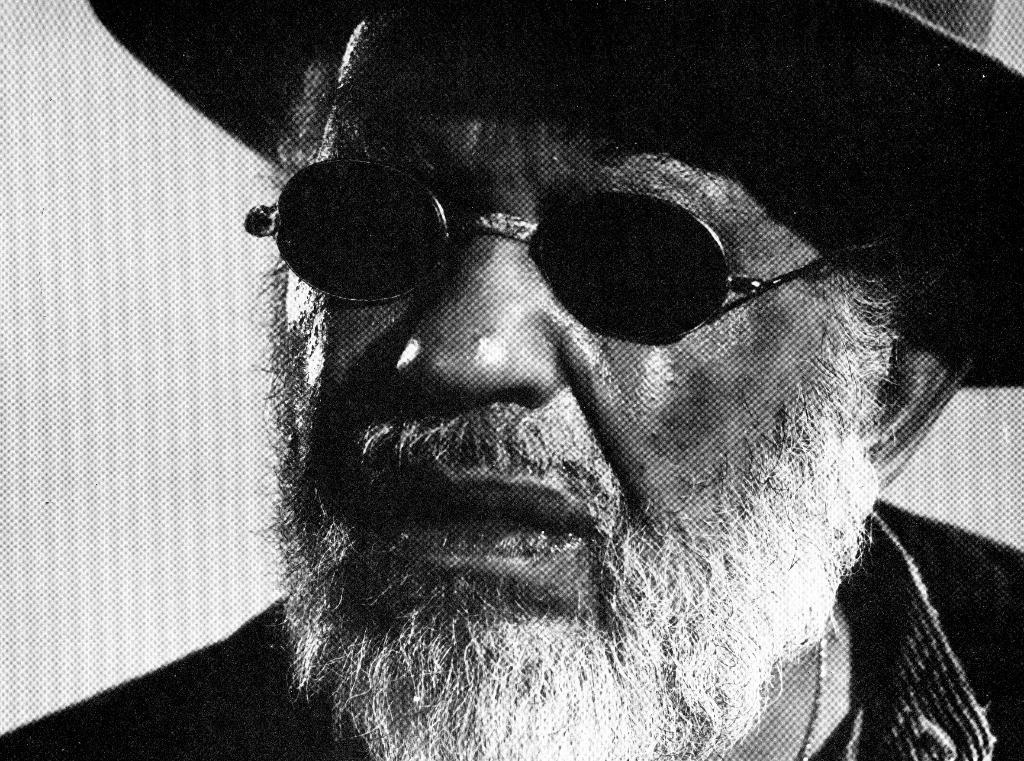Who is present in the image? There is a man in the picture. Can you describe the man's appearance? The man has a white beard and is wearing goggles and a hat. What type of crime is the man committing in the image? There is no indication of a crime being committed in the image; the man is simply wearing goggles, a hat, and has a white beard. Are there any dinosaurs present in the image? No, there are no dinosaurs present in the image. 